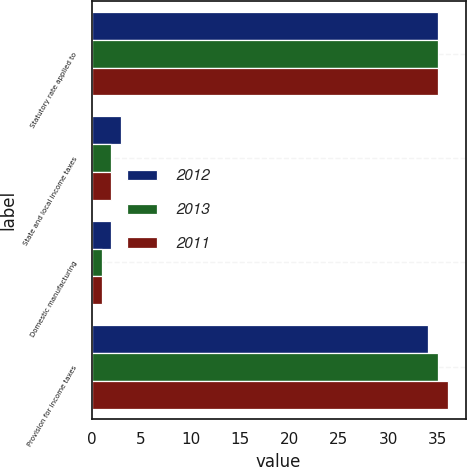Convert chart to OTSL. <chart><loc_0><loc_0><loc_500><loc_500><stacked_bar_chart><ecel><fcel>Statutory rate applied to<fcel>State and local income taxes<fcel>Domestic manufacturing<fcel>Provision for income taxes<nl><fcel>2012<fcel>35<fcel>3<fcel>2<fcel>34<nl><fcel>2013<fcel>35<fcel>2<fcel>1<fcel>35<nl><fcel>2011<fcel>35<fcel>2<fcel>1<fcel>36<nl></chart> 